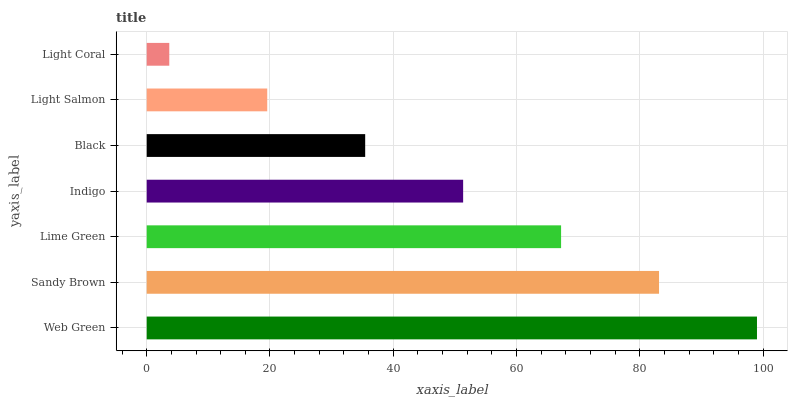Is Light Coral the minimum?
Answer yes or no. Yes. Is Web Green the maximum?
Answer yes or no. Yes. Is Sandy Brown the minimum?
Answer yes or no. No. Is Sandy Brown the maximum?
Answer yes or no. No. Is Web Green greater than Sandy Brown?
Answer yes or no. Yes. Is Sandy Brown less than Web Green?
Answer yes or no. Yes. Is Sandy Brown greater than Web Green?
Answer yes or no. No. Is Web Green less than Sandy Brown?
Answer yes or no. No. Is Indigo the high median?
Answer yes or no. Yes. Is Indigo the low median?
Answer yes or no. Yes. Is Web Green the high median?
Answer yes or no. No. Is Light Salmon the low median?
Answer yes or no. No. 